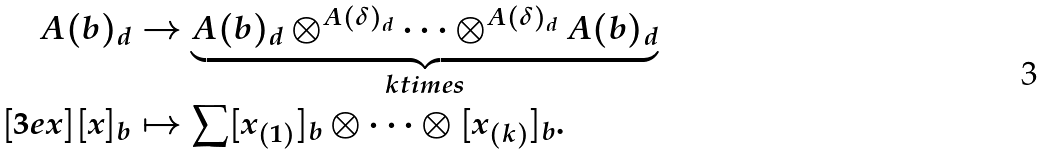<formula> <loc_0><loc_0><loc_500><loc_500>A ( b ) _ { d } & \to \underbrace { A ( b ) _ { d } \otimes ^ { A ( \delta ) _ { d } } \dots \otimes ^ { A ( \delta ) _ { d } } A ( b ) _ { d } } _ { k t i m e s } \\ [ 3 e x ] [ x ] _ { b } & \mapsto \sum [ x _ { ( 1 ) } ] _ { b } \otimes \dots \otimes [ x _ { ( k ) } ] _ { b } .</formula> 